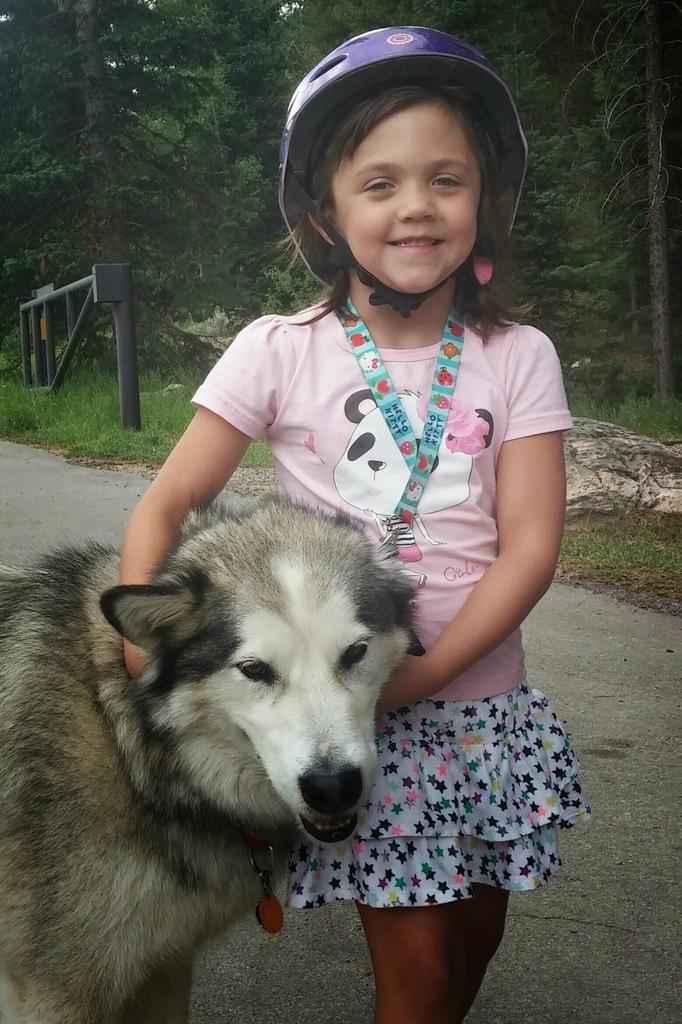Who is present in the image? There is a girl in the image. What is the girl doing in the image? The girl is smiling in the image. What is the girl holding in the image? The girl is holding a dog in the image. What can be seen in the background of the image? There is grass, a stone, and trees in the background of the image. What type of bun is the girl eating in the image? There is no bun present in the image; the girl is holding a dog. Can you see a ghost in the image? No, there is no ghost present in the image. 